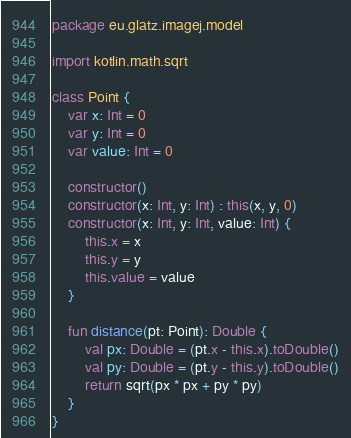Convert code to text. <code><loc_0><loc_0><loc_500><loc_500><_Kotlin_>package eu.glatz.imagej.model

import kotlin.math.sqrt

class Point {
    var x: Int = 0
    var y: Int = 0
    var value: Int = 0

    constructor()
    constructor(x: Int, y: Int) : this(x, y, 0)
    constructor(x: Int, y: Int, value: Int) {
        this.x = x
        this.y = y
        this.value = value
    }

    fun distance(pt: Point): Double {
        val px: Double = (pt.x - this.x).toDouble()
        val py: Double = (pt.y - this.y).toDouble()
        return sqrt(px * px + py * py)
    }
}
</code> 